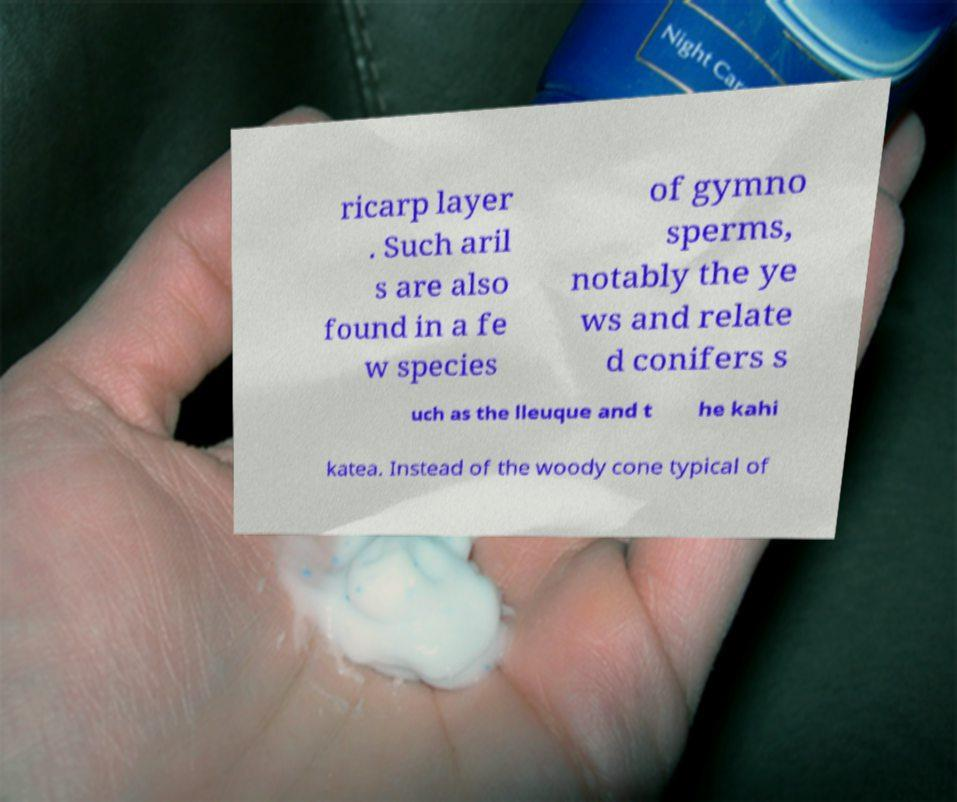Could you assist in decoding the text presented in this image and type it out clearly? ricarp layer . Such aril s are also found in a fe w species of gymno sperms, notably the ye ws and relate d conifers s uch as the lleuque and t he kahi katea. Instead of the woody cone typical of 